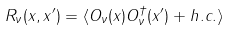<formula> <loc_0><loc_0><loc_500><loc_500>R _ { \nu } ( x , x ^ { \prime } ) = \langle O _ { \nu } ( x ) O _ { \nu } ^ { \dag } ( x ^ { \prime } ) + h . c . \rangle</formula> 